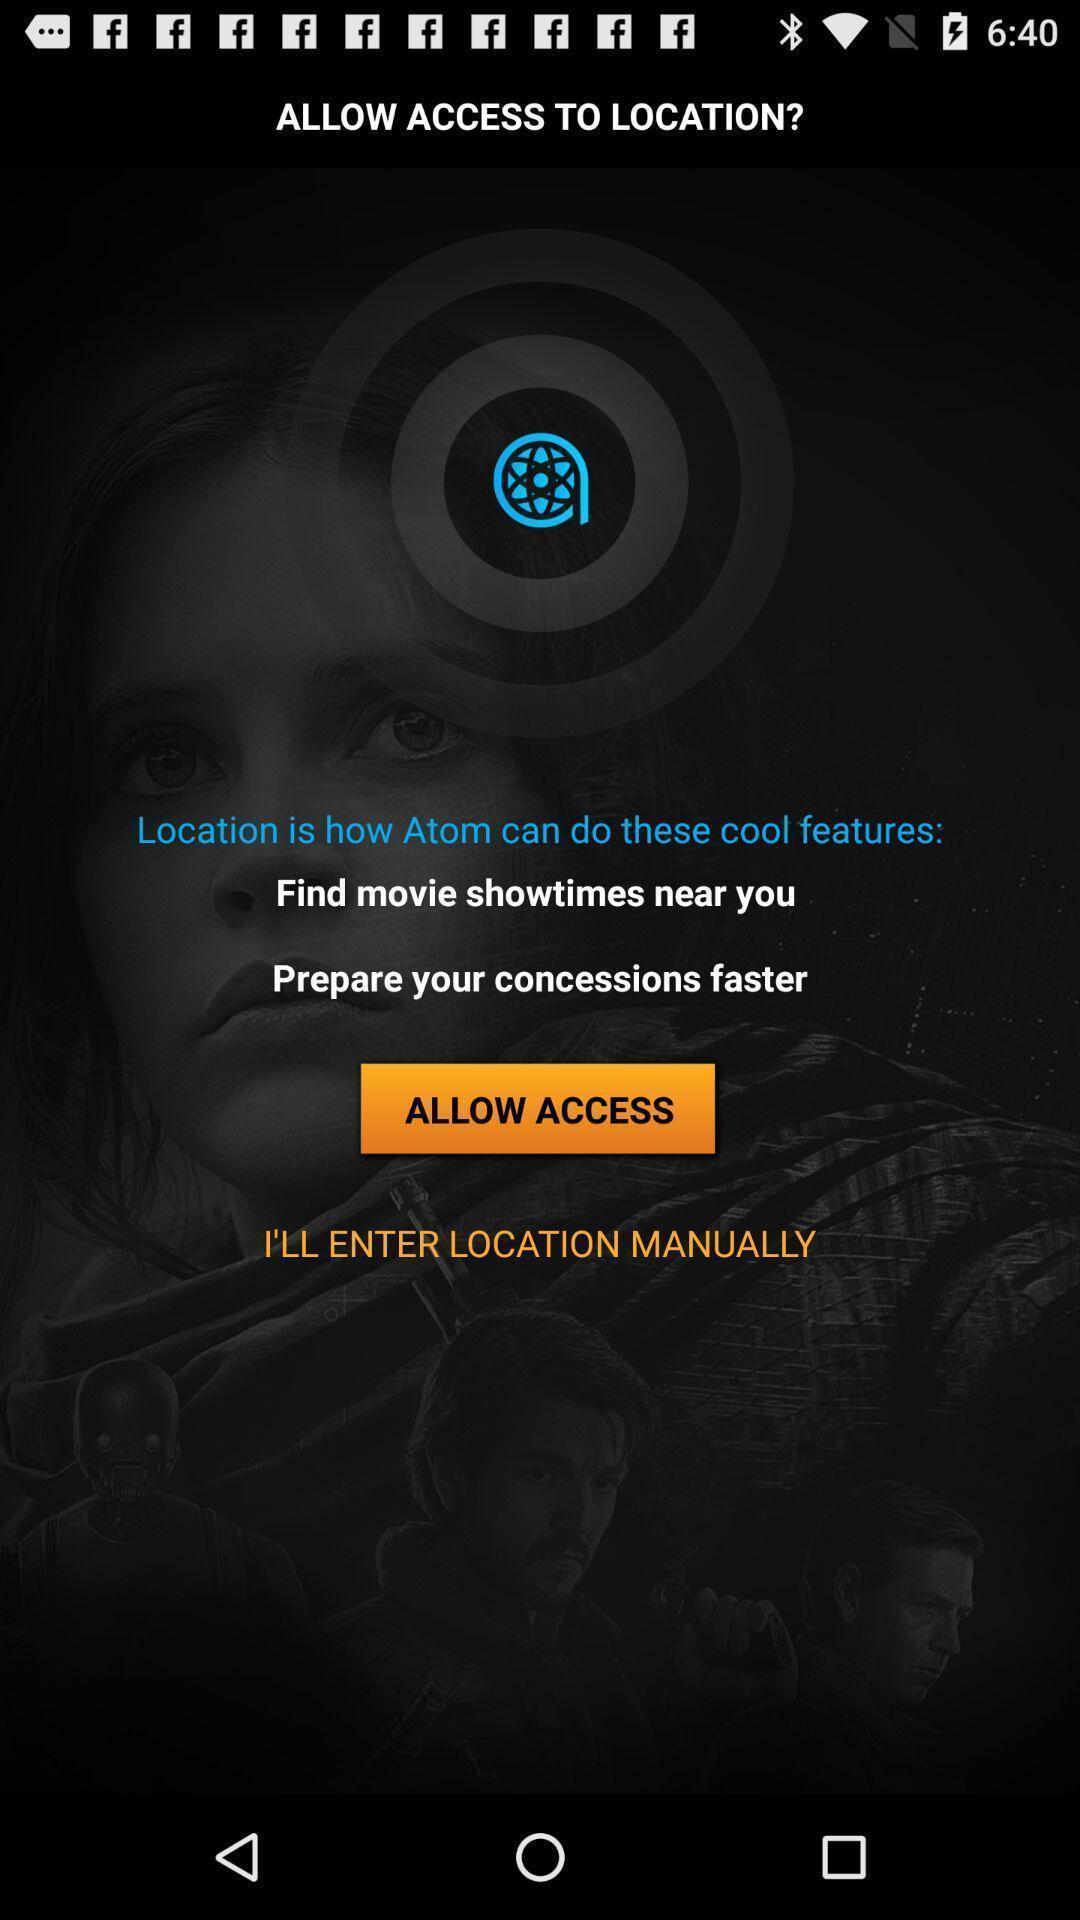Tell me about the visual elements in this screen capture. Page to allow access to location. 